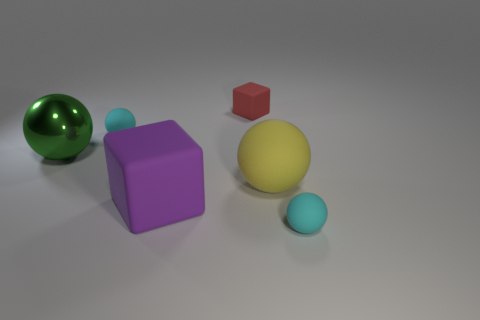Subtract all big metal spheres. How many spheres are left? 3 Subtract all brown blocks. How many cyan balls are left? 2 Add 2 green metallic balls. How many objects exist? 8 Subtract all yellow spheres. How many spheres are left? 3 Subtract all blocks. How many objects are left? 4 Subtract all red spheres. Subtract all yellow cylinders. How many spheres are left? 4 Subtract all small cyan matte balls. Subtract all big yellow balls. How many objects are left? 3 Add 6 large shiny objects. How many large shiny objects are left? 7 Add 6 large cyan metal spheres. How many large cyan metal spheres exist? 6 Subtract 0 yellow cubes. How many objects are left? 6 